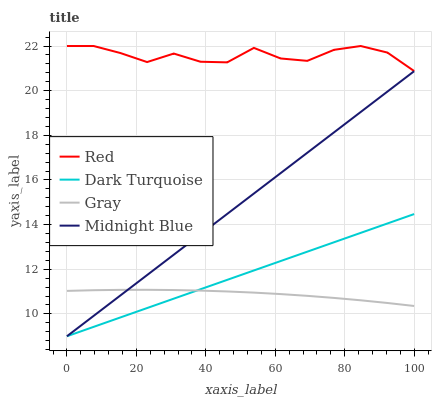Does Gray have the minimum area under the curve?
Answer yes or no. Yes. Does Red have the maximum area under the curve?
Answer yes or no. Yes. Does Midnight Blue have the minimum area under the curve?
Answer yes or no. No. Does Midnight Blue have the maximum area under the curve?
Answer yes or no. No. Is Midnight Blue the smoothest?
Answer yes or no. Yes. Is Red the roughest?
Answer yes or no. Yes. Is Red the smoothest?
Answer yes or no. No. Is Midnight Blue the roughest?
Answer yes or no. No. Does Dark Turquoise have the lowest value?
Answer yes or no. Yes. Does Red have the lowest value?
Answer yes or no. No. Does Red have the highest value?
Answer yes or no. Yes. Does Midnight Blue have the highest value?
Answer yes or no. No. Is Midnight Blue less than Red?
Answer yes or no. Yes. Is Red greater than Midnight Blue?
Answer yes or no. Yes. Does Midnight Blue intersect Dark Turquoise?
Answer yes or no. Yes. Is Midnight Blue less than Dark Turquoise?
Answer yes or no. No. Is Midnight Blue greater than Dark Turquoise?
Answer yes or no. No. Does Midnight Blue intersect Red?
Answer yes or no. No. 